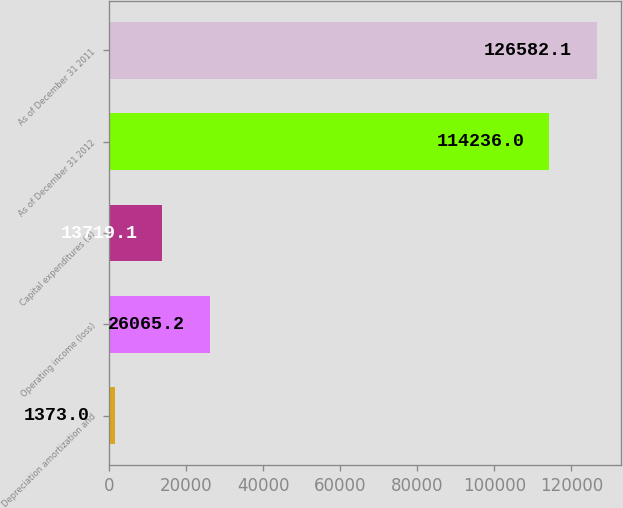Convert chart to OTSL. <chart><loc_0><loc_0><loc_500><loc_500><bar_chart><fcel>Depreciation amortization and<fcel>Operating income (loss)<fcel>Capital expenditures (3)<fcel>As of December 31 2012<fcel>As of December 31 2011<nl><fcel>1373<fcel>26065.2<fcel>13719.1<fcel>114236<fcel>126582<nl></chart> 